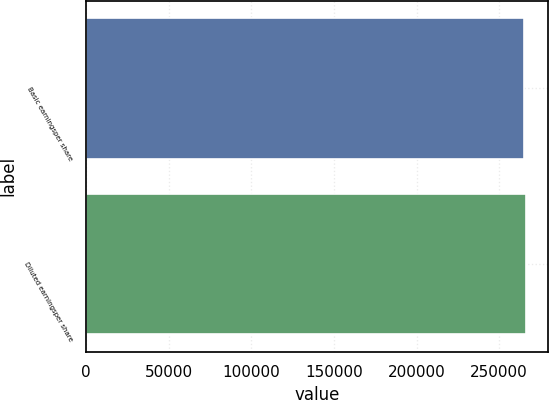Convert chart to OTSL. <chart><loc_0><loc_0><loc_500><loc_500><bar_chart><fcel>Basic earningsper share<fcel>Diluted earningsper share<nl><fcel>265155<fcel>266105<nl></chart> 